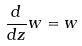<formula> <loc_0><loc_0><loc_500><loc_500>\frac { d } { d z } w = w</formula> 